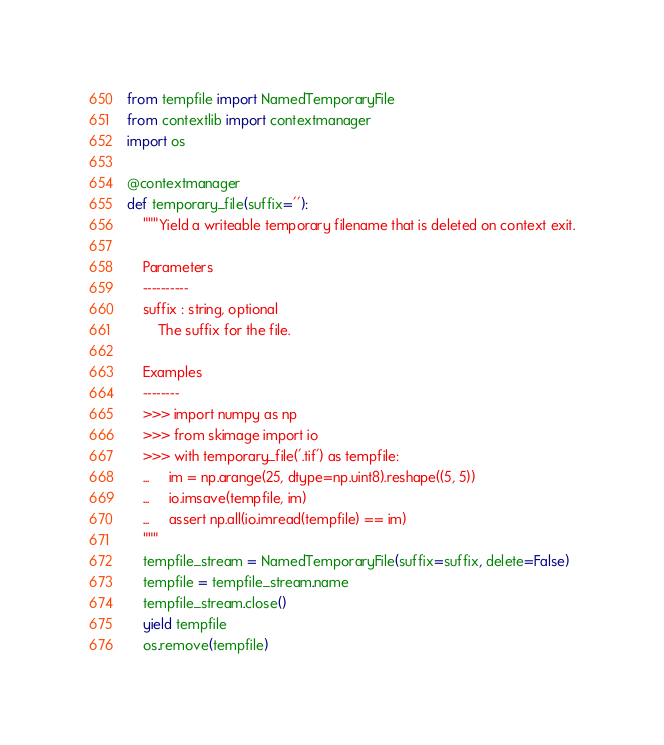Convert code to text. <code><loc_0><loc_0><loc_500><loc_500><_Python_>from tempfile import NamedTemporaryFile
from contextlib import contextmanager
import os

@contextmanager
def temporary_file(suffix=''):
    """Yield a writeable temporary filename that is deleted on context exit.

    Parameters
    ----------
    suffix : string, optional
        The suffix for the file.

    Examples
    --------
    >>> import numpy as np
    >>> from skimage import io
    >>> with temporary_file('.tif') as tempfile:
    ...     im = np.arange(25, dtype=np.uint8).reshape((5, 5))
    ...     io.imsave(tempfile, im)
    ...     assert np.all(io.imread(tempfile) == im)
    """
    tempfile_stream = NamedTemporaryFile(suffix=suffix, delete=False)
    tempfile = tempfile_stream.name
    tempfile_stream.close()
    yield tempfile
    os.remove(tempfile)
</code> 